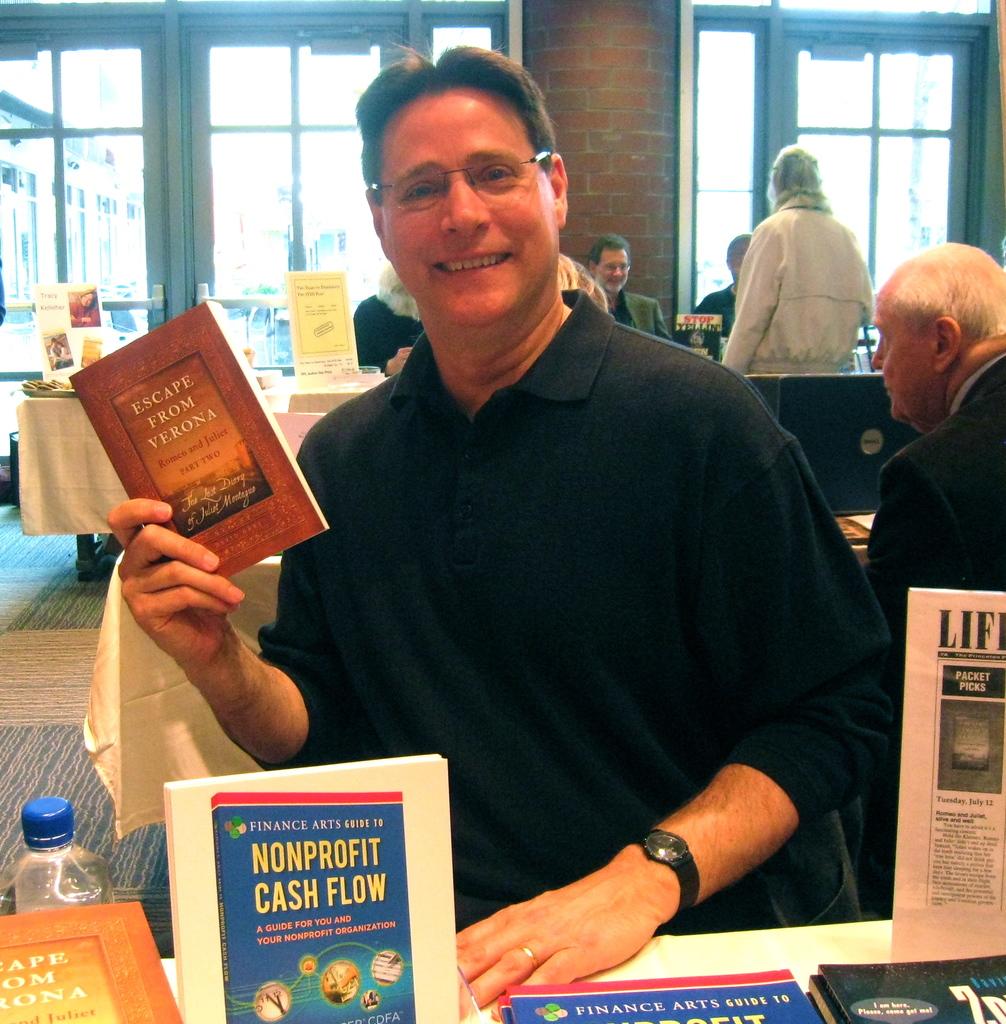What kind of cash flow?
Provide a succinct answer. Nonprofit. What is the title of the book he is holding?
Give a very brief answer. Escape from verona. 